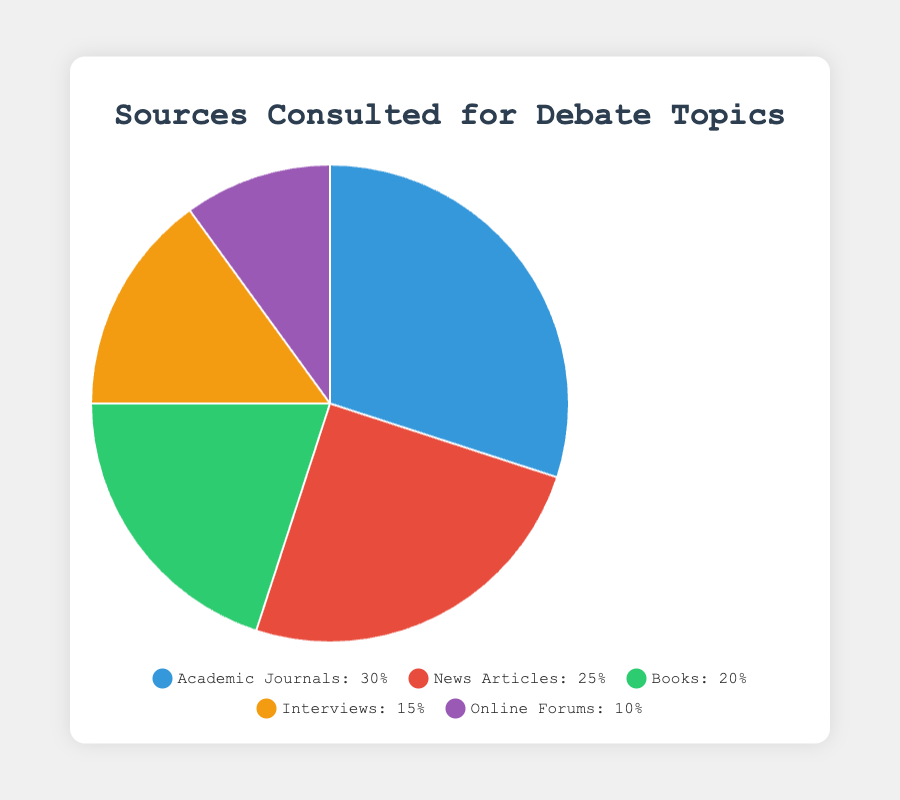Which source is consulted the most for debate topics? By looking at the pie chart, we see which slice has the largest percentage labeled. Academic Journals have the highest percentage at 30%.
Answer: Academic Journals Which source is consulted the least for debate topics? Observing the pie chart, the smallest slice represents the least consulted source. Online Forums have the smallest percentage at 10%.
Answer: Online Forums What's the combined percentage of sources that are consulted equally or less than 20%? Adding percentages of sources that are 20% or less: Books (20%) + Interviews (15%) + Online Forums (10%) = 20% + 15% + 10% = 45%
Answer: 45% How much more are Academic Journals consulted compared to Online Forums? Subtract the percentage of Online Forums from Academic Journals: 30% (Academic Journals) - 10% (Online Forums) = 20%
Answer: 20% Which sources together make up more than 50% of the consultation for debate topics? Adding percentages to find which combinations exceed 50%: Academic Journals (30%) + News Articles (25%) = 55%, which is more than 50%.
Answer: Academic Journals and News Articles What is the visual color representation of News Articles in the pie chart? By observing the pie chart legend and correlating the source with its color, News Articles are represented by the red slice.
Answer: Red What is the total percentage of sources other than News Articles? Subtract the percentage of News Articles from 100% to get the remaining sources: 100% - 25% (News Articles) = 75%
Answer: 75% How many sources are consulted more than 20%? Identify the slices with percentages above 20%: Academic Journals (30%) and News Articles (25%). Count them: 2 sources.
Answer: 2 If we combine Books and Interviews, what total percentage do they contribute to the sources consulted? Add the percentages of Books and Interviews: 20% (Books) + 15% (Interviews) = 35%
Answer: 35% What is the average percentage of the sources consulted for debate topics? Sum all percentages and divide by the number of sources: (30% + 25% + 20% + 15% + 10%) / 5 = 100% / 5 = 20%
Answer: 20% 